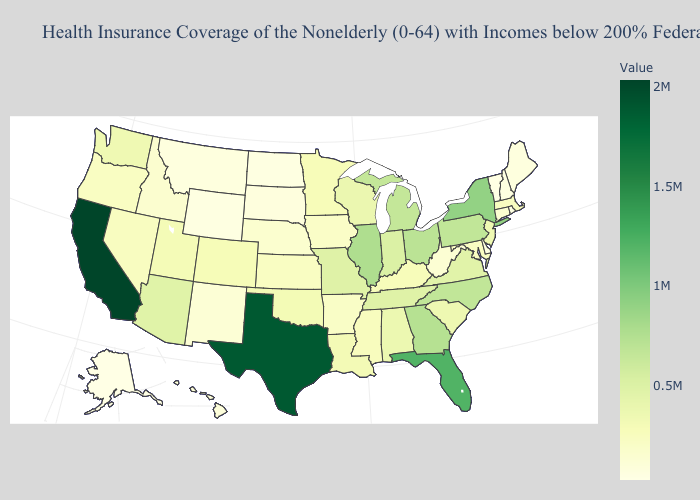Does Nebraska have a higher value than California?
Be succinct. No. Which states have the lowest value in the USA?
Keep it brief. Alaska. Among the states that border Colorado , does Wyoming have the lowest value?
Answer briefly. Yes. Which states have the lowest value in the USA?
Write a very short answer. Alaska. Does California have the highest value in the USA?
Write a very short answer. Yes. 